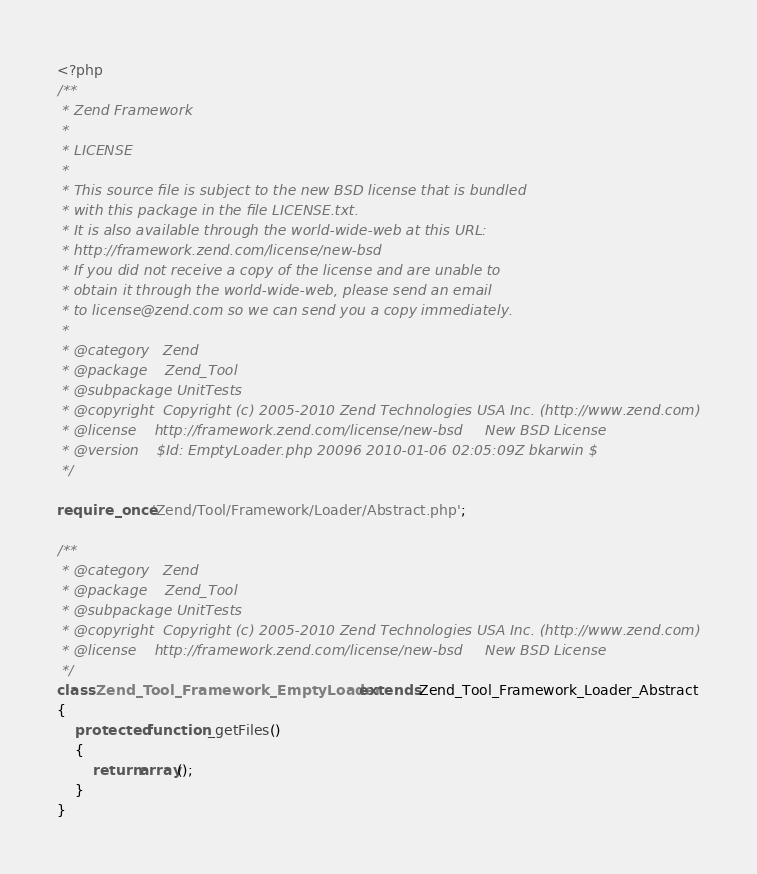<code> <loc_0><loc_0><loc_500><loc_500><_PHP_><?php
/**
 * Zend Framework
 *
 * LICENSE
 *
 * This source file is subject to the new BSD license that is bundled
 * with this package in the file LICENSE.txt.
 * It is also available through the world-wide-web at this URL:
 * http://framework.zend.com/license/new-bsd
 * If you did not receive a copy of the license and are unable to
 * obtain it through the world-wide-web, please send an email
 * to license@zend.com so we can send you a copy immediately.
 *
 * @category   Zend
 * @package    Zend_Tool
 * @subpackage UnitTests
 * @copyright  Copyright (c) 2005-2010 Zend Technologies USA Inc. (http://www.zend.com)
 * @license    http://framework.zend.com/license/new-bsd     New BSD License
 * @version    $Id: EmptyLoader.php 20096 2010-01-06 02:05:09Z bkarwin $
 */

require_once 'Zend/Tool/Framework/Loader/Abstract.php';

/**
 * @category   Zend
 * @package    Zend_Tool
 * @subpackage UnitTests
 * @copyright  Copyright (c) 2005-2010 Zend Technologies USA Inc. (http://www.zend.com)
 * @license    http://framework.zend.com/license/new-bsd     New BSD License
 */
class Zend_Tool_Framework_EmptyLoader extends Zend_Tool_Framework_Loader_Abstract
{
    protected function _getFiles()
    {
        return array();
    }
}
</code> 